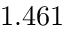<formula> <loc_0><loc_0><loc_500><loc_500>1 . 4 6 1</formula> 